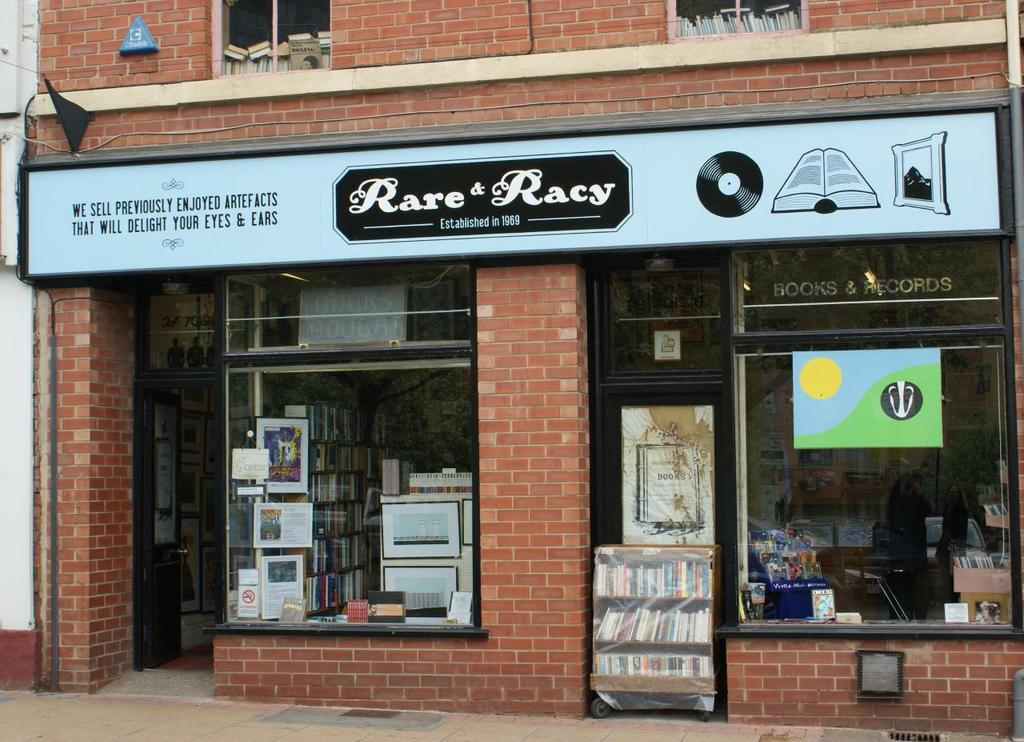<image>
Create a compact narrative representing the image presented. A bookcase is sitting outside of a store called Rare and Racy. 